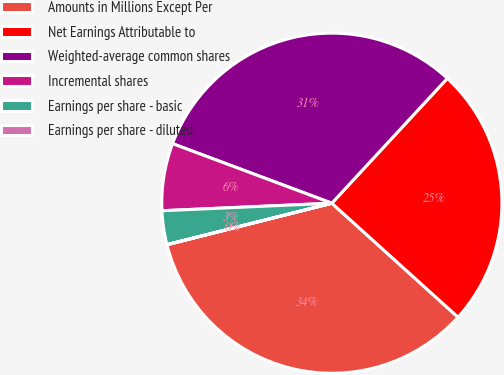Convert chart. <chart><loc_0><loc_0><loc_500><loc_500><pie_chart><fcel>Amounts in Millions Except Per<fcel>Net Earnings Attributable to<fcel>Weighted-average common shares<fcel>Incremental shares<fcel>Earnings per share - basic<fcel>Earnings per share - diluted<nl><fcel>34.38%<fcel>24.81%<fcel>31.19%<fcel>6.4%<fcel>3.21%<fcel>0.01%<nl></chart> 